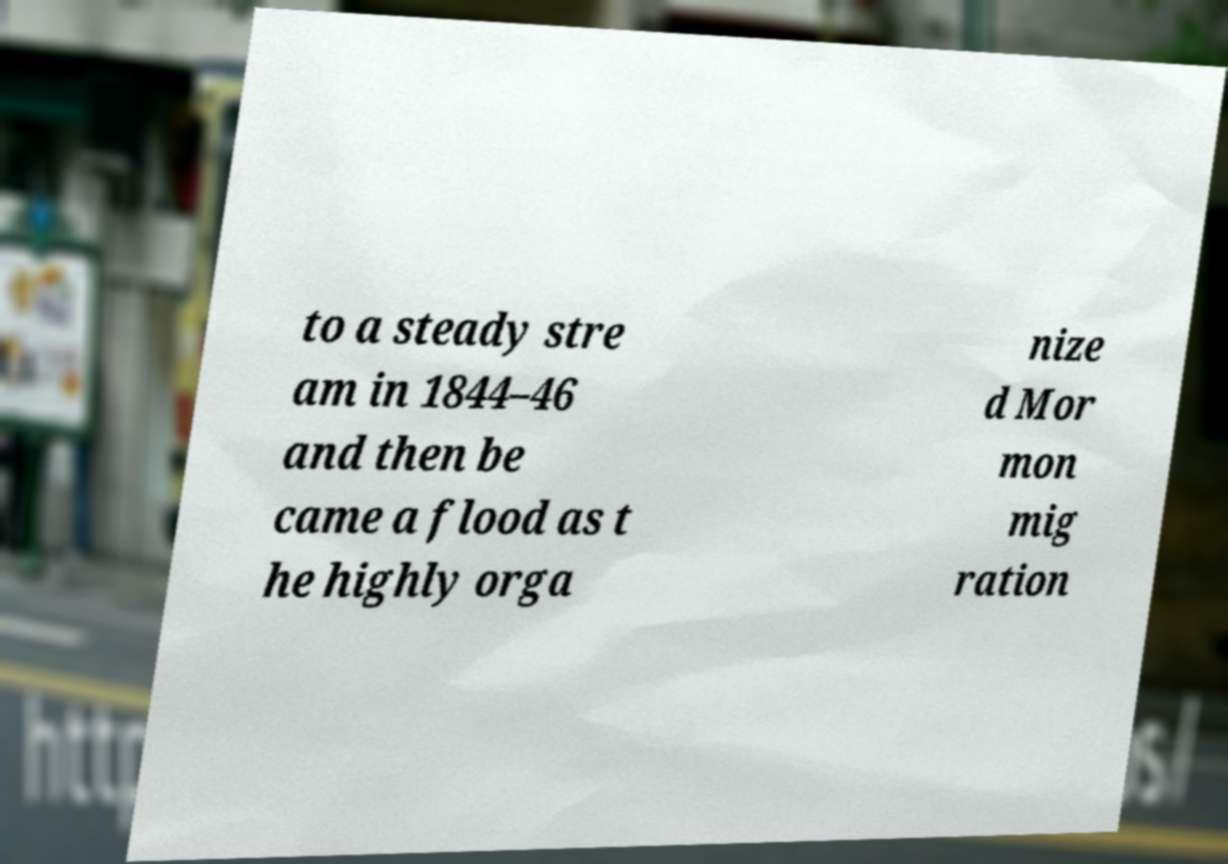There's text embedded in this image that I need extracted. Can you transcribe it verbatim? to a steady stre am in 1844–46 and then be came a flood as t he highly orga nize d Mor mon mig ration 